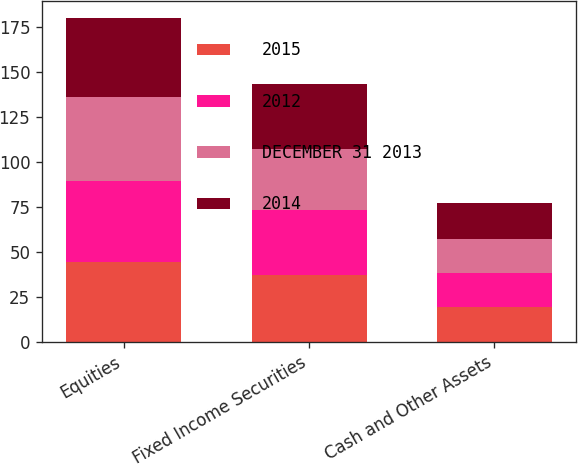Convert chart to OTSL. <chart><loc_0><loc_0><loc_500><loc_500><stacked_bar_chart><ecel><fcel>Equities<fcel>Fixed Income Securities<fcel>Cash and Other Assets<nl><fcel>2015<fcel>44<fcel>37<fcel>19<nl><fcel>2012<fcel>45<fcel>36<fcel>19<nl><fcel>DECEMBER 31 2013<fcel>47<fcel>34<fcel>19<nl><fcel>2014<fcel>44<fcel>36<fcel>20<nl></chart> 